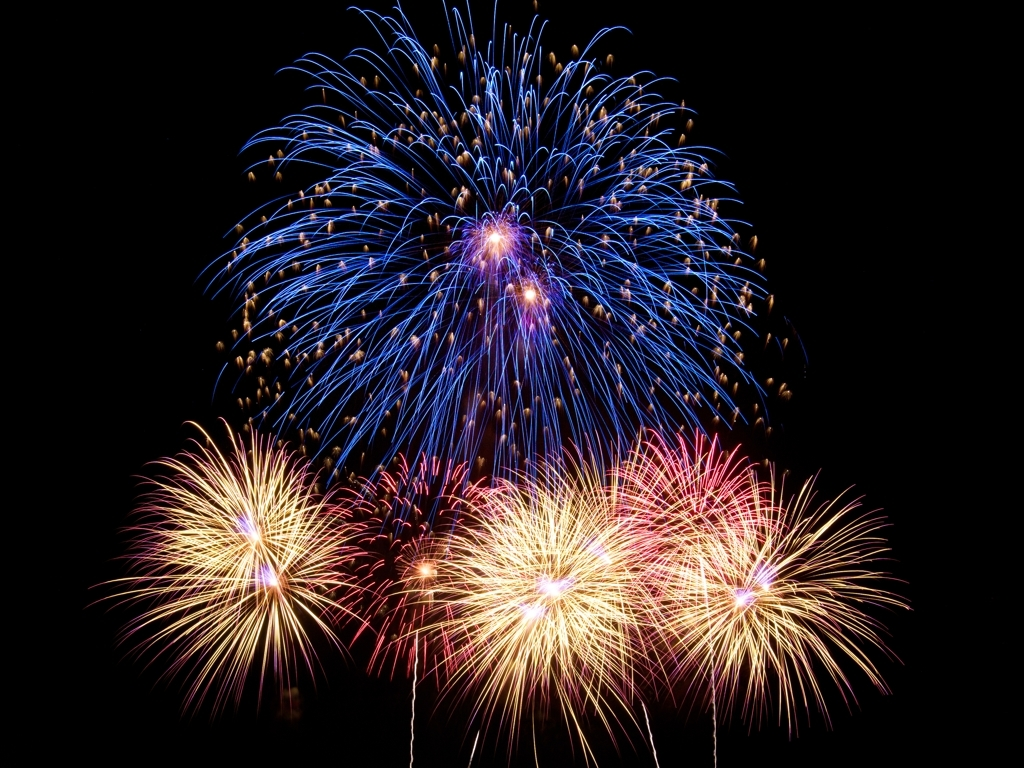What photography techniques can be used to capture fireworks effectively? To capture fireworks effectively, photographers often use a tripod to stabilize the camera, set a slow shutter speed to capture the trails of light, and use a remote shutter release to avoid shaking the camera. They may also adjust the aperture and ISO settings to manage the exposure and clarity of the image. Could this image be improved with any specific techniques? This image is already quite striking, but additional techniques like using a wider aperture could potentially allow for capturing sharper details of the fireworks against the dark sky. Bracketing exposure times might also capture more dynamic range in the brightness and color of the fireworks. 